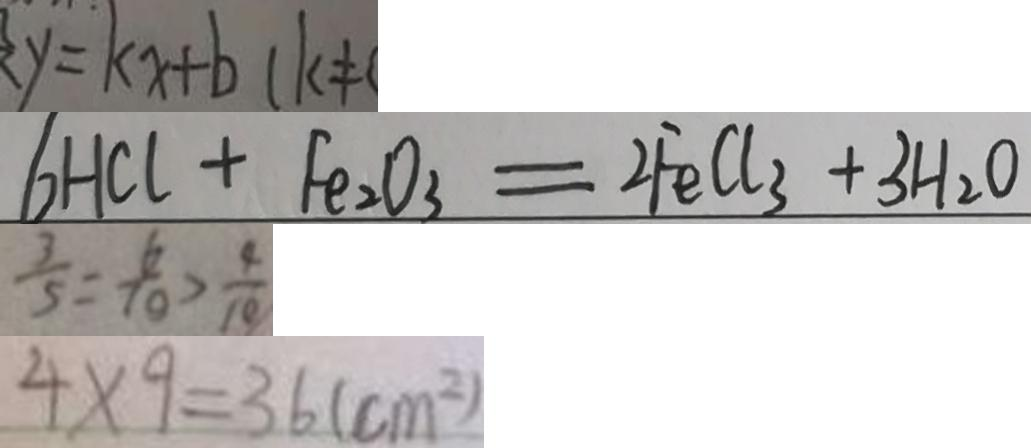<formula> <loc_0><loc_0><loc_500><loc_500>y = k x + b ( k \neq 
 6 H C l + F e _ { 2 } O _ { 3 } = 2 F e C l _ { 3 } + 3 H _ { 2 } O 
 \frac { 3 } { 5 } = \frac { 6 } { 1 0 } > \frac { 4 } { 1 0 } 
 4 \times 9 = 3 6 ( c m ^ { 2 } )</formula> 